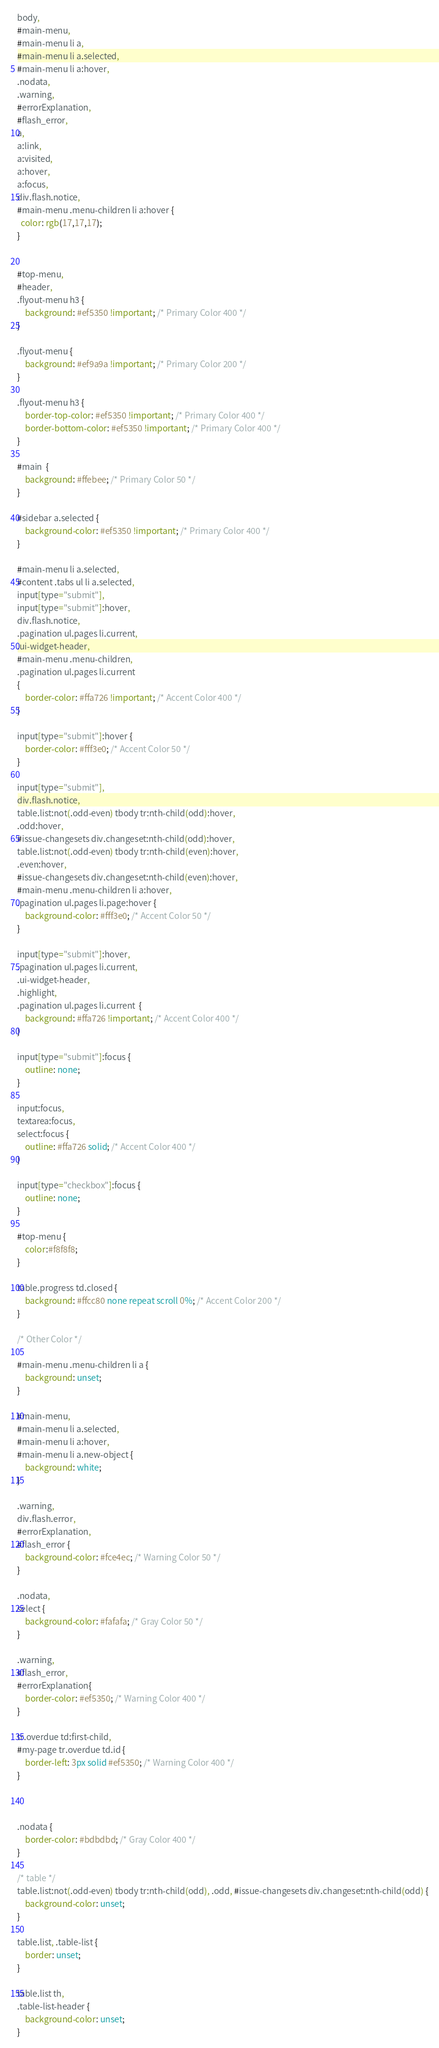<code> <loc_0><loc_0><loc_500><loc_500><_CSS_>body,
#main-menu,
#main-menu li a,
#main-menu li a.selected,
#main-menu li a:hover,
.nodata,
.warning,
#errorExplanation,
#flash_error,
a, 
a:link, 
a:visited,
a:hover,
a:focus,
div.flash.notice,
#main-menu .menu-children li a:hover {
  color: rgb(17,17,17);
}


#top-menu,
#header,
.flyout-menu h3 {
    background: #ef5350 !important; /* Primary Color 400 */
}

.flyout-menu {
    background: #ef9a9a !important; /* Primary Color 200 */
}

.flyout-menu h3 {
    border-top-color: #ef5350 !important; /* Primary Color 400 */
    border-bottom-color: #ef5350 !important; /* Primary Color 400 */
}

#main  {
    background: #ffebee; /* Primary Color 50 */
}

#sidebar a.selected {
    background-color: #ef5350 !important; /* Primary Color 400 */
}

#main-menu li a.selected,
#content .tabs ul li a.selected,
input[type="submit"],
input[type="submit"]:hover,
div.flash.notice,
.pagination ul.pages li.current,
.ui-widget-header,
#main-menu .menu-children,
.pagination ul.pages li.current
{
    border-color: #ffa726 !important; /* Accent Color 400 */
}

input[type="submit"]:hover {
    border-color: #fff3e0; /* Accent Color 50 */
}

input[type="submit"], 
div.flash.notice,
table.list:not(.odd-even) tbody tr:nth-child(odd):hover,
.odd:hover,
#issue-changesets div.changeset:nth-child(odd):hover,
table.list:not(.odd-even) tbody tr:nth-child(even):hover,
.even:hover,
#issue-changesets div.changeset:nth-child(even):hover,
#main-menu .menu-children li a:hover,
.pagination ul.pages li.page:hover {
    background-color: #fff3e0; /* Accent Color 50 */
}

input[type="submit"]:hover,
.pagination ul.pages li.current,
.ui-widget-header,
.highlight,
.pagination ul.pages li.current  {
    background: #ffa726 !important; /* Accent Color 400 */
}

input[type="submit"]:focus {
    outline: none;
}

input:focus,
textarea:focus,
select:focus {
    outline: #ffa726 solid; /* Accent Color 400 */
}

input[type="checkbox"]:focus {
    outline: none;
}

#top-menu {
    color:#f8f8f8;
}

table.progress td.closed {
    background: #ffcc80 none repeat scroll 0%; /* Accent Color 200 */
}

/* Other Color */

#main-menu .menu-children li a {
    background: unset;
}

#main-menu,
#main-menu li a.selected,
#main-menu li a:hover,
#main-menu li a.new-object {
    background: white;
}

.warning,
div.flash.error,
#errorExplanation,
#flash_error {
    background-color: #fce4ec; /* Warning Color 50 */
}

.nodata,
select {
    background-color: #fafafa; /* Gray Color 50 */
}

.warning,
#flash_error,
#errorExplanation{
    border-color: #ef5350; /* Warning Color 400 */
}

tr.overdue td:first-child,
#my-page tr.overdue td.id {
    border-left: 3px solid #ef5350; /* Warning Color 400 */
}



.nodata {
    border-color: #bdbdbd; /* Gray Color 400 */
}

/* table */
table.list:not(.odd-even) tbody tr:nth-child(odd), .odd, #issue-changesets div.changeset:nth-child(odd) {
    background-color: unset;
}

table.list, .table-list {
    border: unset;
}

table.list th,
.table-list-header {
    background-color: unset;
}
</code> 